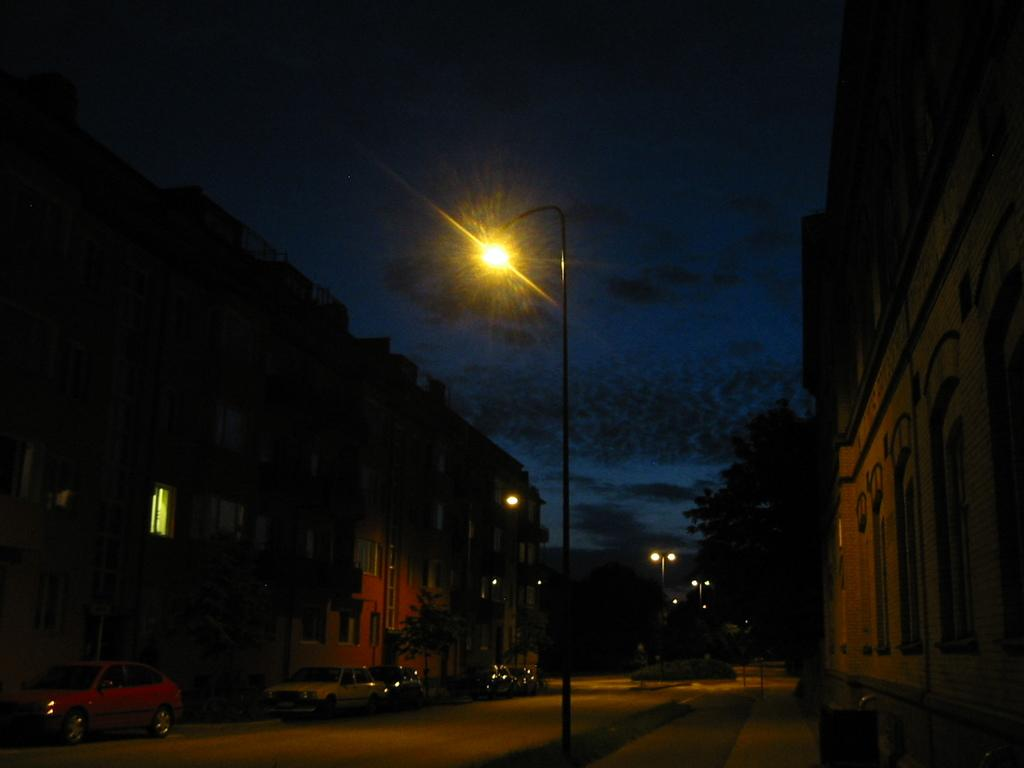What is present on the road in the image? There are vehicles on the road in the image. What can be seen behind the vehicles? There are trees and buildings behind the vehicles. What type of structures are present in the image? There are poles with lights in the image. What is visible in the background of the image? The sky is visible in the image. What type of fruit is hanging from the trees in the image? There is no fruit visible in the image; only trees, buildings, and vehicles are present. 